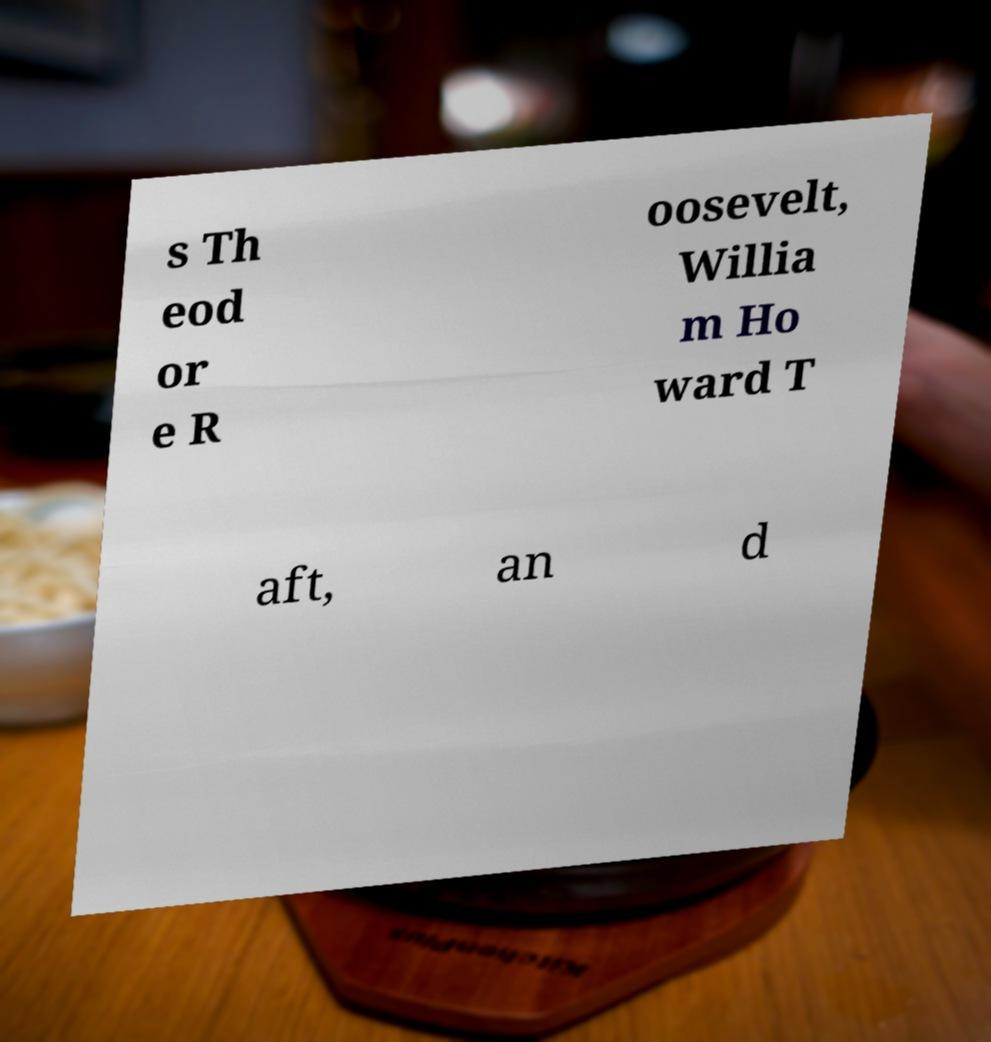There's text embedded in this image that I need extracted. Can you transcribe it verbatim? s Th eod or e R oosevelt, Willia m Ho ward T aft, an d 